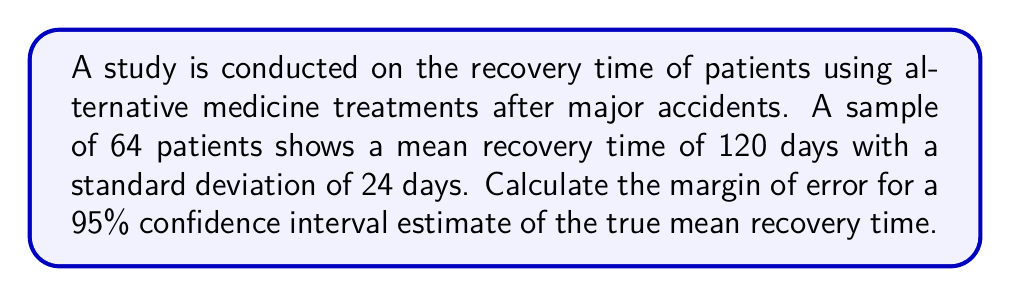Can you answer this question? To calculate the margin of error for a 95% confidence interval, we'll follow these steps:

1. Identify the given information:
   - Sample size (n) = 64
   - Sample mean (x̄) = 120 days
   - Sample standard deviation (s) = 24 days
   - Confidence level = 95%

2. Determine the critical value (z-score) for a 95% confidence level:
   The z-score for a 95% confidence level is 1.96.

3. Calculate the standard error of the mean:
   $$ SE = \frac{s}{\sqrt{n}} = \frac{24}{\sqrt{64}} = \frac{24}{8} = 3 $$

4. Calculate the margin of error:
   $$ ME = z \cdot SE = 1.96 \cdot 3 = 5.88 $$

5. Round the result to two decimal places:
   Margin of Error ≈ 5.88 days

This means we can be 95% confident that the true population mean recovery time falls within ±5.88 days of our sample mean.
Answer: 5.88 days 